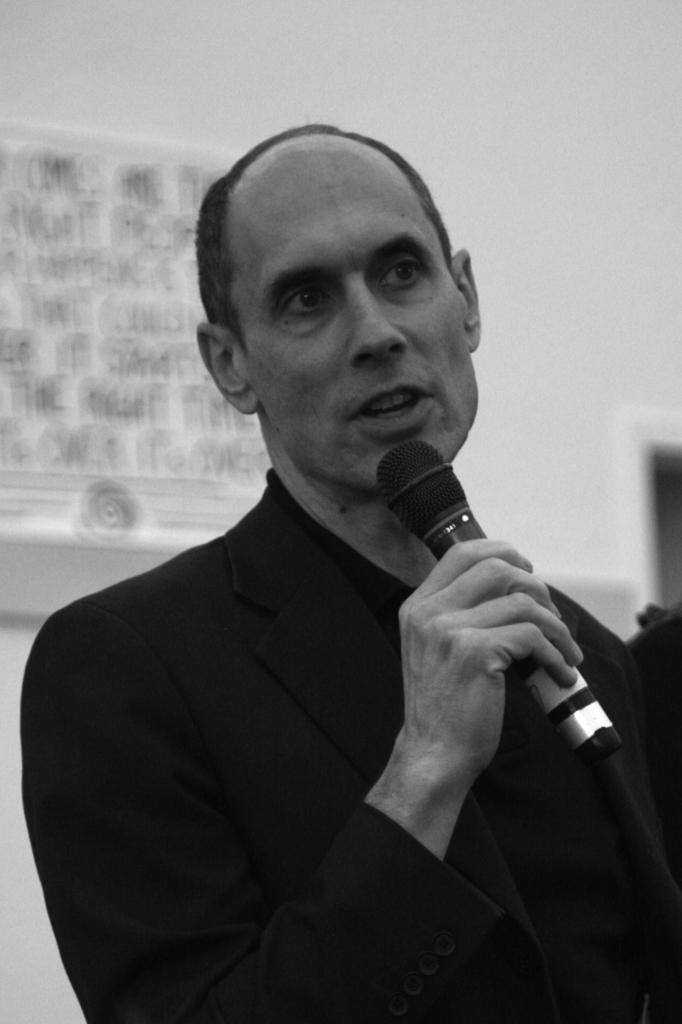Who is present in the image? There is a man in the image. What is the man wearing? The man is wearing a coat. What is the man holding in his hand? The man is holding a mic in his hand. What can be seen in the background of the image? There is a wall in the background of the image. What is the color scheme of the image? The image is black and white. What type of pickle is the man holding in the image? There is no pickle present in the image; the man is holding a mic. Is the man standing in quicksand in the image? There is no indication of quicksand in the image; the man is standing on a surface that is not identifiable from the provided facts. 